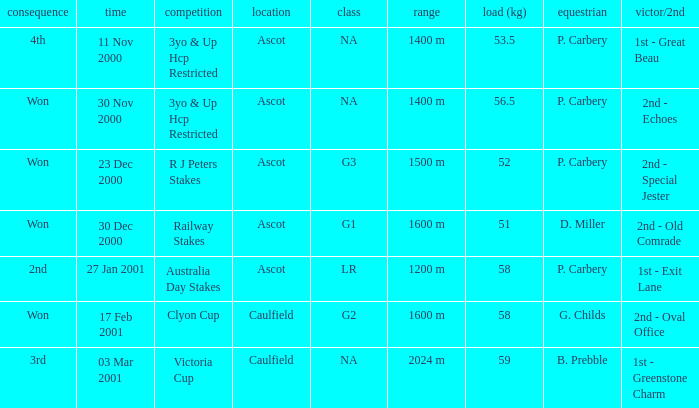What was the result for the railway stakes race? Won. 